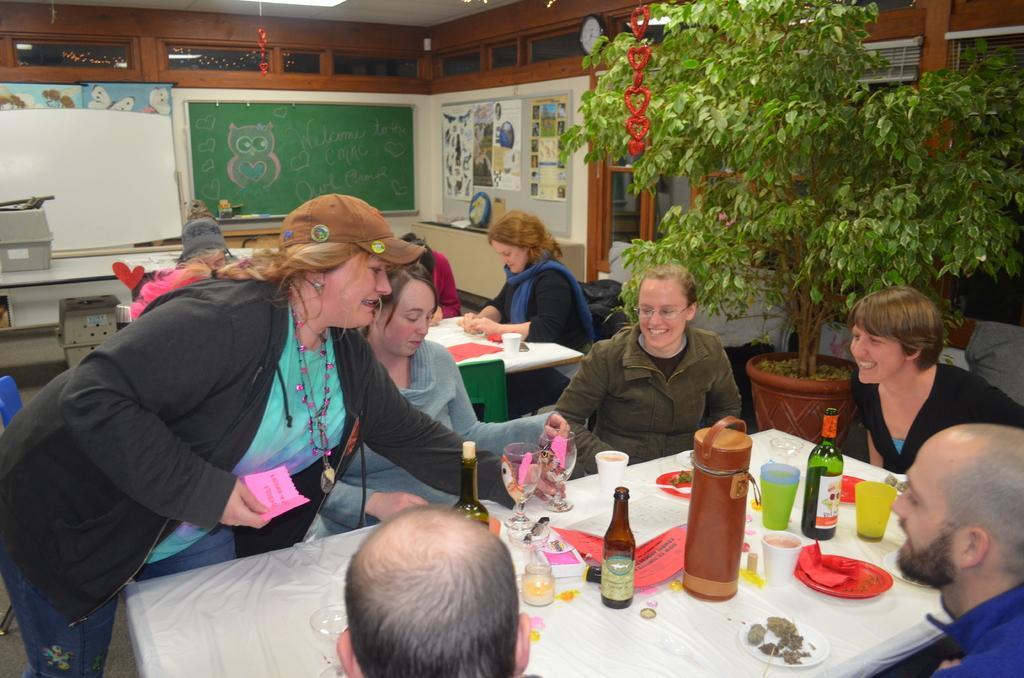Describe this image in one or two sentences. In the image we can see there are many people sitting and one is standing. They are wearing clothes and some of them are wearing caps. There are chairs and tables, on the table, we can see the bottles, glasses, plates, wine glasses and other objects. Here we can see the tree, board, posters, window, the clock and the pot. 